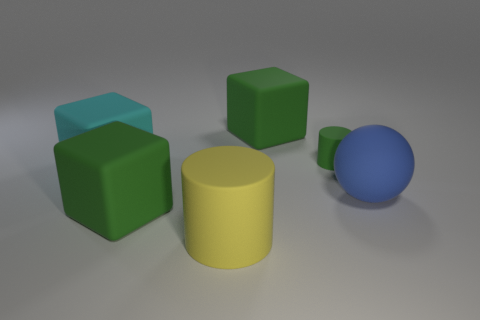Subtract all brown balls. How many green cubes are left? 2 Subtract 1 cubes. How many cubes are left? 2 Subtract all large green matte blocks. How many blocks are left? 1 Add 4 big yellow metallic blocks. How many objects exist? 10 Subtract all balls. How many objects are left? 5 Subtract all large things. Subtract all big blue metallic objects. How many objects are left? 1 Add 4 large balls. How many large balls are left? 5 Add 5 large green spheres. How many large green spheres exist? 5 Subtract 0 red spheres. How many objects are left? 6 